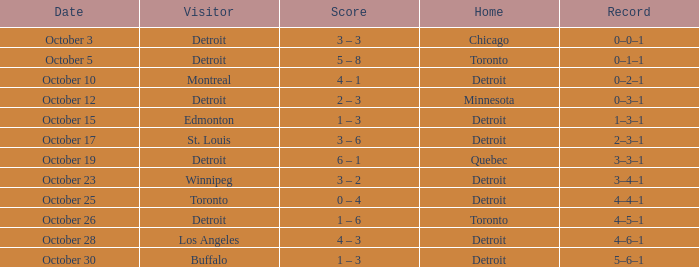Identify the residence with toronto as a guest. Detroit. 